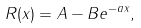<formula> <loc_0><loc_0><loc_500><loc_500>R ( x ) = A - B e ^ { - a x } ,</formula> 